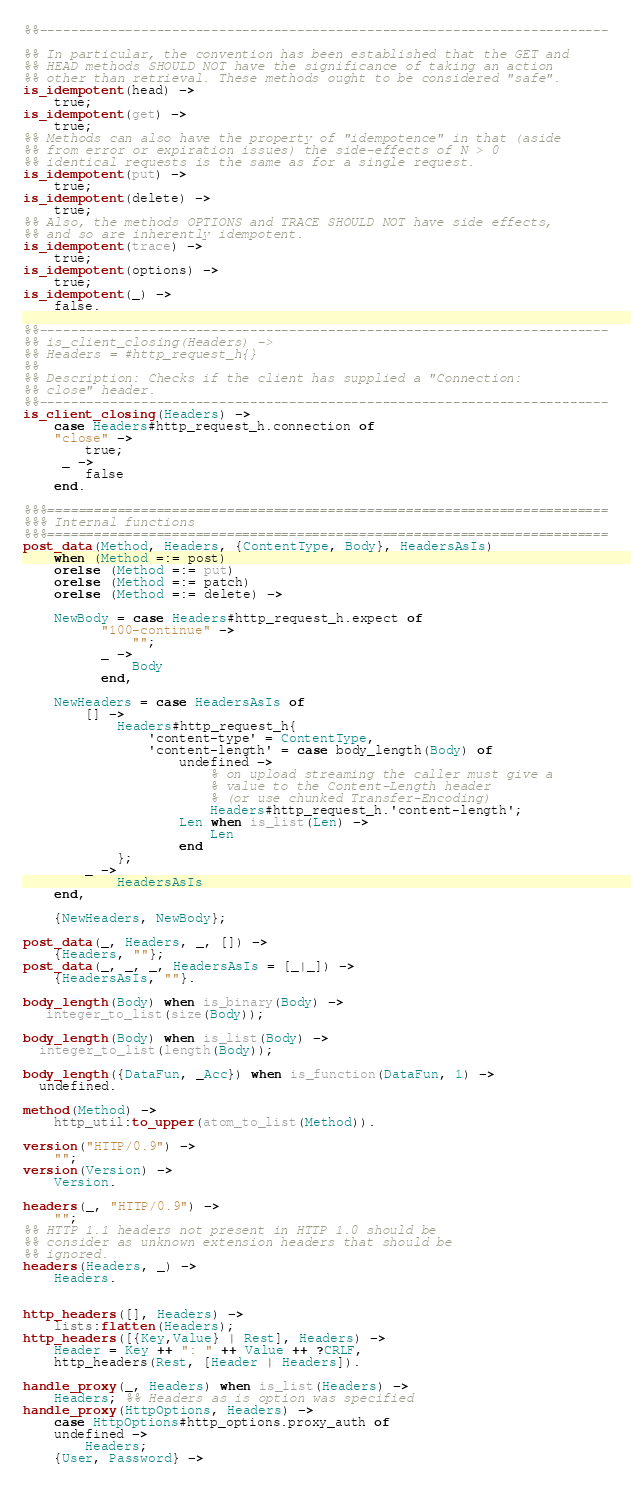<code> <loc_0><loc_0><loc_500><loc_500><_Erlang_>%%-------------------------------------------------------------------------

%% In particular, the convention has been established that the GET and
%% HEAD methods SHOULD NOT have the significance of taking an action
%% other than retrieval. These methods ought to be considered "safe".
is_idempotent(head) -> 
    true;
is_idempotent(get) ->
    true;
%% Methods can also have the property of "idempotence" in that (aside
%% from error or expiration issues) the side-effects of N > 0
%% identical requests is the same as for a single request.
is_idempotent(put) -> 
    true;
is_idempotent(delete) ->
    true;
%% Also, the methods OPTIONS and TRACE SHOULD NOT have side effects,
%% and so are inherently idempotent.
is_idempotent(trace) ->
    true;
is_idempotent(options) ->
    true;
is_idempotent(_) ->
    false.

%%-------------------------------------------------------------------------
%% is_client_closing(Headers) ->
%% Headers = #http_request_h{}
%%                                   
%% Description: Checks if the client has supplied a "Connection:
%% close" header.
%%-------------------------------------------------------------------------
is_client_closing(Headers) ->
    case Headers#http_request_h.connection of
	"close" ->
	    true;
	 _ ->
	    false
    end.

%%%========================================================================
%%% Internal functions
%%%========================================================================
post_data(Method, Headers, {ContentType, Body}, HeadersAsIs)
    when (Method =:= post)
    orelse (Method =:= put)
    orelse (Method =:= patch)
    orelse (Method =:= delete) ->

    NewBody = case Headers#http_request_h.expect of
          "100-continue" ->
              "";
          _ ->
              Body
          end,

    NewHeaders = case HeadersAsIs of
        [] ->
            Headers#http_request_h{
                'content-type' = ContentType,
                'content-length' = case body_length(Body) of
                    undefined ->
                        % on upload streaming the caller must give a
                        % value to the Content-Length header
                        % (or use chunked Transfer-Encoding)
                        Headers#http_request_h.'content-length';
                    Len when is_list(Len) ->
                        Len
                    end
            };
        _ ->
            HeadersAsIs
    end,

    {NewHeaders, NewBody};

post_data(_, Headers, _, []) ->
    {Headers, ""};
post_data(_, _, _, HeadersAsIs = [_|_]) ->
    {HeadersAsIs, ""}.

body_length(Body) when is_binary(Body) ->
   integer_to_list(size(Body));

body_length(Body) when is_list(Body) ->
  integer_to_list(length(Body));

body_length({DataFun, _Acc}) when is_function(DataFun, 1) ->
  undefined.

method(Method) ->
    http_util:to_upper(atom_to_list(Method)).

version("HTTP/0.9") ->
    "";
version(Version) ->
    Version.

headers(_, "HTTP/0.9") ->
    "";
%% HTTP 1.1 headers not present in HTTP 1.0 should be
%% consider as unknown extension headers that should be
%% ignored. 
headers(Headers, _) ->
    Headers.


http_headers([], Headers) ->
    lists:flatten(Headers);
http_headers([{Key,Value} | Rest], Headers) ->
    Header = Key ++ ": " ++ Value ++ ?CRLF,
    http_headers(Rest, [Header | Headers]).

handle_proxy(_, Headers) when is_list(Headers) ->
    Headers; %% Headers as is option was specified
handle_proxy(HttpOptions, Headers) ->
    case HttpOptions#http_options.proxy_auth of
	undefined ->
	    Headers;
	{User, Password} -></code> 